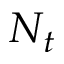Convert formula to latex. <formula><loc_0><loc_0><loc_500><loc_500>N _ { t }</formula> 